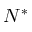<formula> <loc_0><loc_0><loc_500><loc_500>N ^ { * }</formula> 